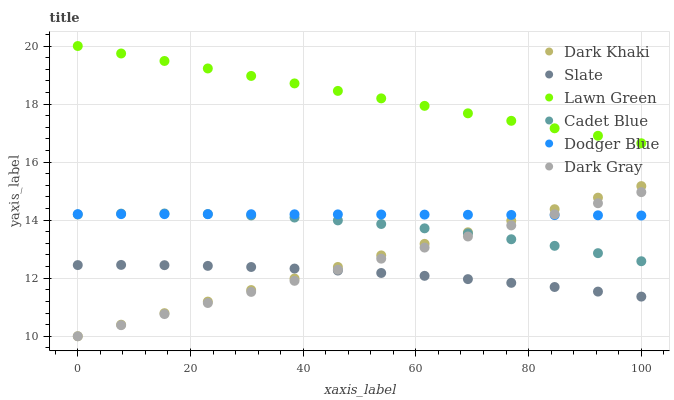Does Slate have the minimum area under the curve?
Answer yes or no. Yes. Does Lawn Green have the maximum area under the curve?
Answer yes or no. Yes. Does Cadet Blue have the minimum area under the curve?
Answer yes or no. No. Does Cadet Blue have the maximum area under the curve?
Answer yes or no. No. Is Dark Gray the smoothest?
Answer yes or no. Yes. Is Cadet Blue the roughest?
Answer yes or no. Yes. Is Slate the smoothest?
Answer yes or no. No. Is Slate the roughest?
Answer yes or no. No. Does Dark Gray have the lowest value?
Answer yes or no. Yes. Does Cadet Blue have the lowest value?
Answer yes or no. No. Does Lawn Green have the highest value?
Answer yes or no. Yes. Does Cadet Blue have the highest value?
Answer yes or no. No. Is Dark Khaki less than Lawn Green?
Answer yes or no. Yes. Is Cadet Blue greater than Slate?
Answer yes or no. Yes. Does Slate intersect Dark Khaki?
Answer yes or no. Yes. Is Slate less than Dark Khaki?
Answer yes or no. No. Is Slate greater than Dark Khaki?
Answer yes or no. No. Does Dark Khaki intersect Lawn Green?
Answer yes or no. No. 